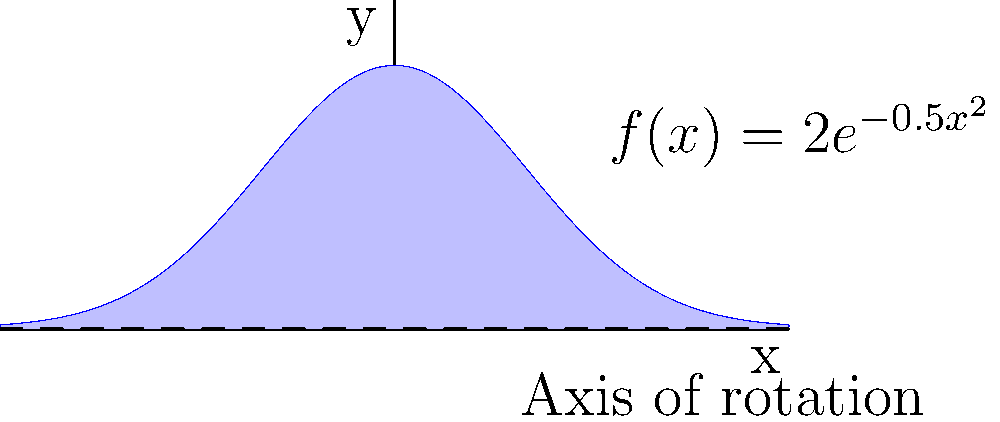In a brain imaging study, the cross-sectional area of a specific brain region is modeled by the function $f(x) = 2e^{-0.5x^2}$ cm², where $x$ is the distance in centimeters from the center of the region. If we rotate this function around the x-axis to create a 3D model of the brain region, what is the total volume of this region in cubic centimeters? (Round your answer to two decimal places) To solve this problem, we need to use the method of integration for volumes of revolution. Here's a step-by-step approach:

1) The volume of a solid of revolution is given by the formula:
   $V = \pi \int_{a}^{b} [f(x)]^2 dx$

2) In this case, $f(x) = 2e^{-0.5x^2}$, and we need to integrate from $-\infty$ to $\infty$ since the function approaches zero as $x$ approaches $\pm\infty$. So our integral becomes:
   $V = \pi \int_{-\infty}^{\infty} [2e^{-0.5x^2}]^2 dx$

3) Simplify the integrand:
   $V = \pi \int_{-\infty}^{\infty} 4e^{-x^2} dx$

4) This integral can be solved using the Gaussian integral formula:
   $\int_{-\infty}^{\infty} e^{-ax^2} dx = \sqrt{\frac{\pi}{a}}$

5) In our case, $a=1$, so:
   $V = 4\pi \int_{-\infty}^{\infty} e^{-x^2} dx = 4\pi \sqrt{\pi}$

6) Calculate the final value:
   $V = 4\pi \sqrt{\pi} \approx 12.5664$ cm³

7) Rounding to two decimal places:
   $V \approx 12.57$ cm³
Answer: 12.57 cm³ 